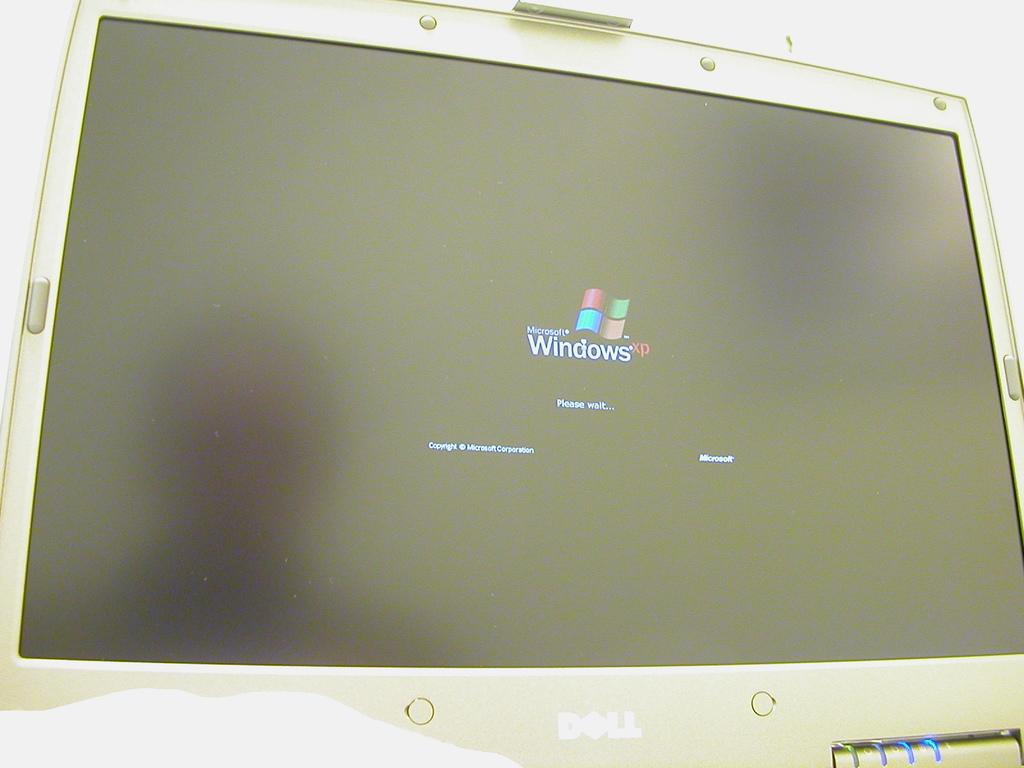What is the name of the operating system?
Your answer should be very brief. Windows xp. What does the computer want you to do?
Offer a terse response. Wait. 